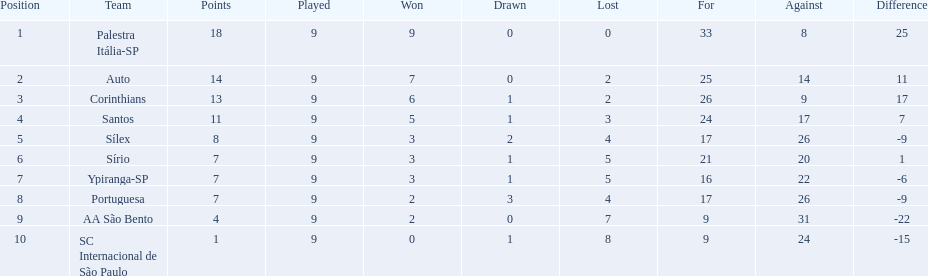In 1926, how many football teams participated in brazil? Palestra Itália-SP, Auto, Corinthians, Santos, Sílex, Sírio, Ypiranga-SP, Portuguesa, AA São Bento, SC Internacional de São Paulo. During that season, what was the greatest number of victories achieved? 9. Which team secured the first place with 9 wins in the 1926 season? Palestra Itália-SP. 